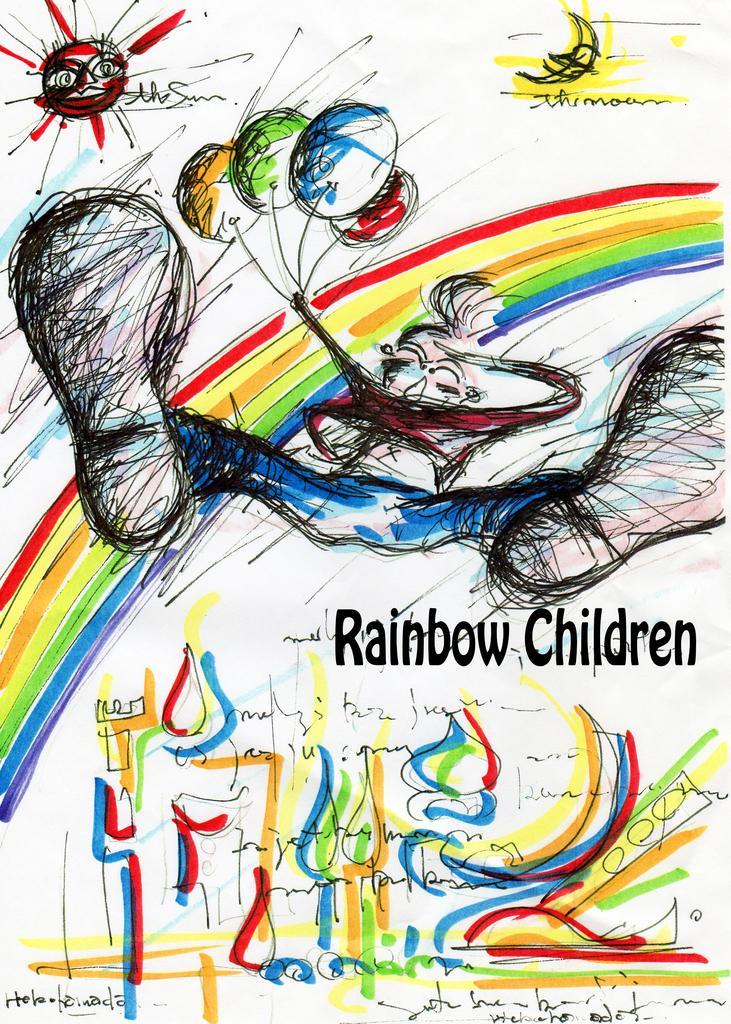In one or two sentences, can you explain what this image depicts? In this image we can see an advertisement. 